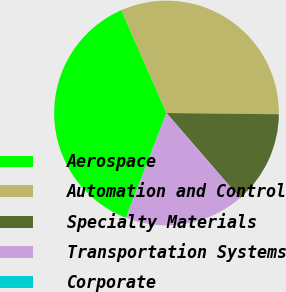Convert chart to OTSL. <chart><loc_0><loc_0><loc_500><loc_500><pie_chart><fcel>Aerospace<fcel>Automation and Control<fcel>Specialty Materials<fcel>Transportation Systems<fcel>Corporate<nl><fcel>37.5%<fcel>31.76%<fcel>13.48%<fcel>17.23%<fcel>0.03%<nl></chart> 